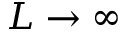<formula> <loc_0><loc_0><loc_500><loc_500>L \rightarrow \infty</formula> 